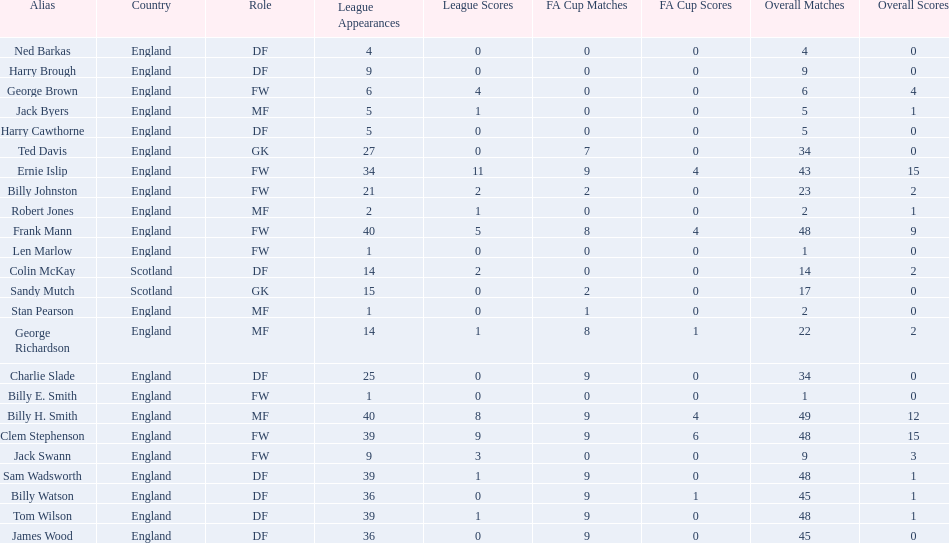Can you identify the first name listed? Ned Barkas. 